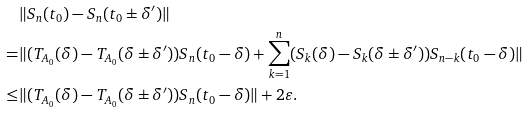Convert formula to latex. <formula><loc_0><loc_0><loc_500><loc_500>& \| S _ { n } ( t _ { 0 } ) - S _ { n } ( t _ { 0 } \pm \delta ^ { \prime } ) \| \\ = & \| ( T _ { A _ { 0 } } ( \delta ) - T _ { A _ { 0 } } ( \delta \pm \delta ^ { \prime } ) ) S _ { n } ( t _ { 0 } - \delta ) + \sum _ { k = 1 } ^ { n } ( S _ { k } ( \delta ) - S _ { k } ( \delta \pm \delta ^ { \prime } ) ) S _ { n - k } ( t _ { 0 } - \delta ) \| \\ \leq & \| ( T _ { A _ { 0 } } ( \delta ) - T _ { A _ { 0 } } ( \delta \pm \delta ^ { \prime } ) ) S _ { n } ( t _ { 0 } - \delta ) \| + 2 \varepsilon .</formula> 